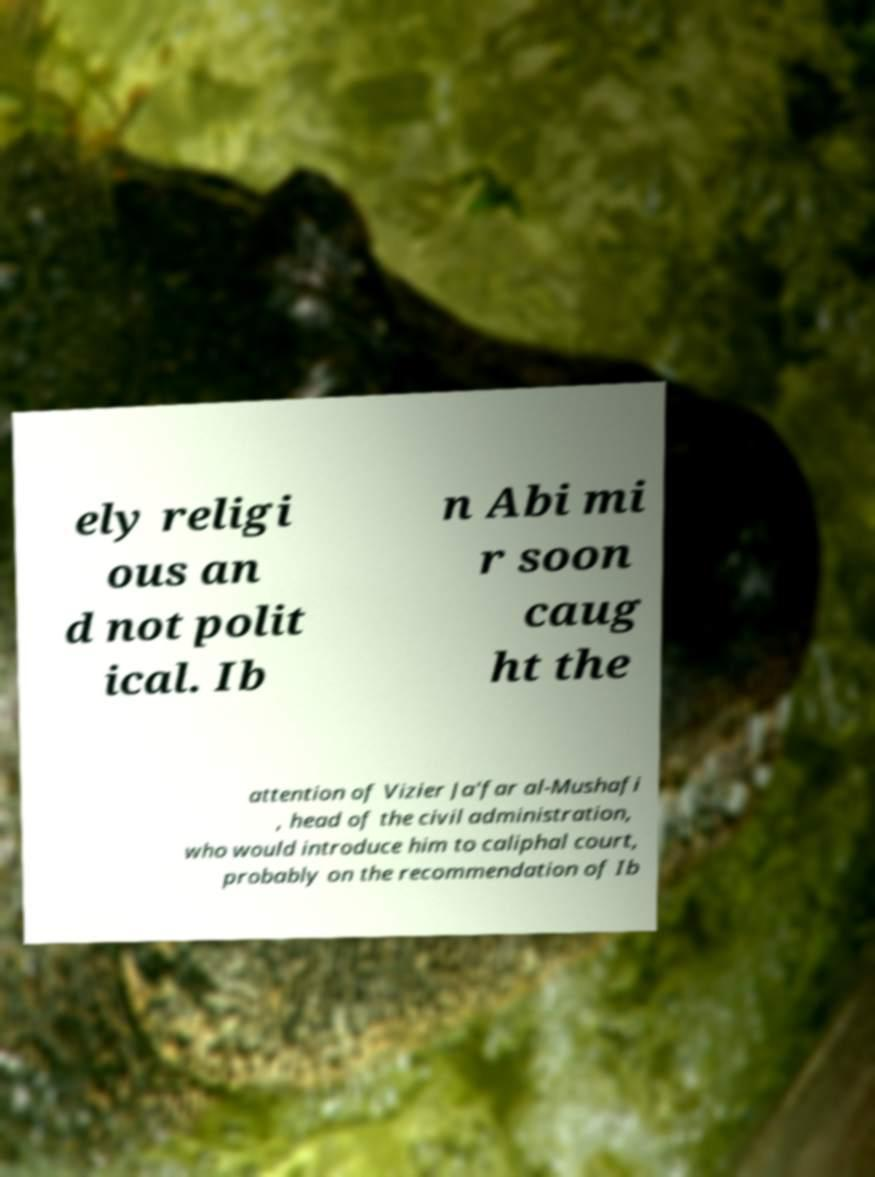Can you accurately transcribe the text from the provided image for me? ely religi ous an d not polit ical. Ib n Abi mi r soon caug ht the attention of Vizier Ja'far al-Mushafi , head of the civil administration, who would introduce him to caliphal court, probably on the recommendation of Ib 